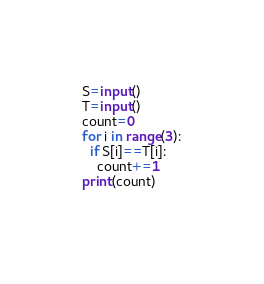<code> <loc_0><loc_0><loc_500><loc_500><_Python_>S=input()
T=input()
count=0
for i in range(3):
  if S[i]==T[i]:
    count+=1
print(count)
  
</code> 